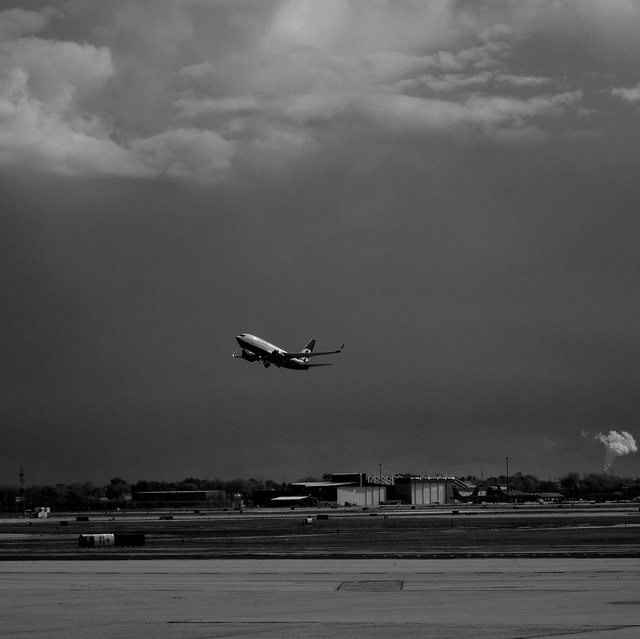Describe the objects in this image and their specific colors. I can see a airplane in gray, black, darkgray, and lightgray tones in this image. 